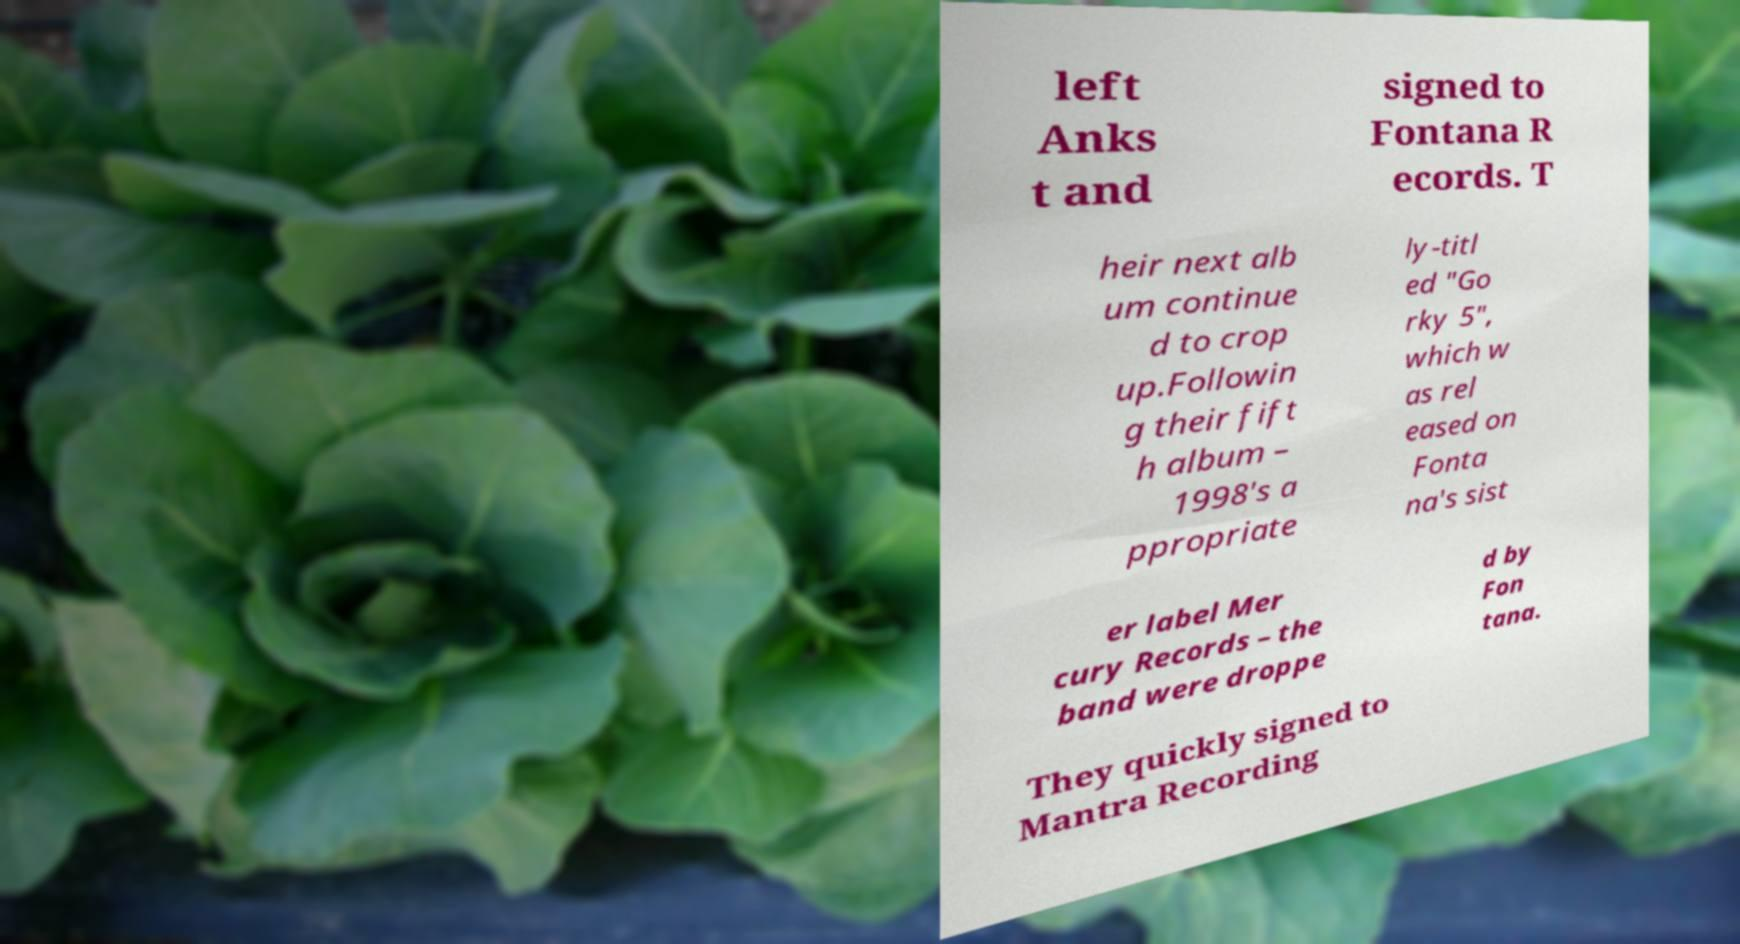Please read and relay the text visible in this image. What does it say? left Anks t and signed to Fontana R ecords. T heir next alb um continue d to crop up.Followin g their fift h album – 1998's a ppropriate ly-titl ed "Go rky 5", which w as rel eased on Fonta na's sist er label Mer cury Records – the band were droppe d by Fon tana. They quickly signed to Mantra Recording 